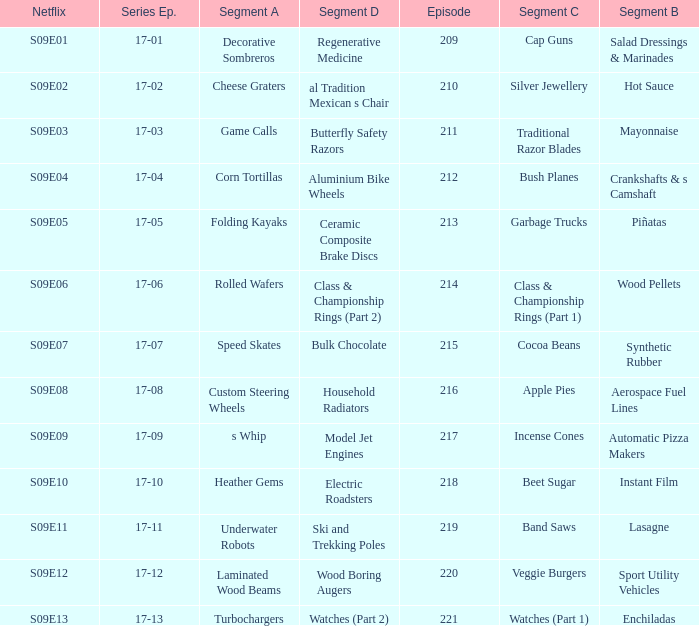Segment B of aerospace fuel lines has what segment A? Custom Steering Wheels. 